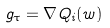Convert formula to latex. <formula><loc_0><loc_0><loc_500><loc_500>g _ { \tau } = \nabla Q _ { i } ( w )</formula> 